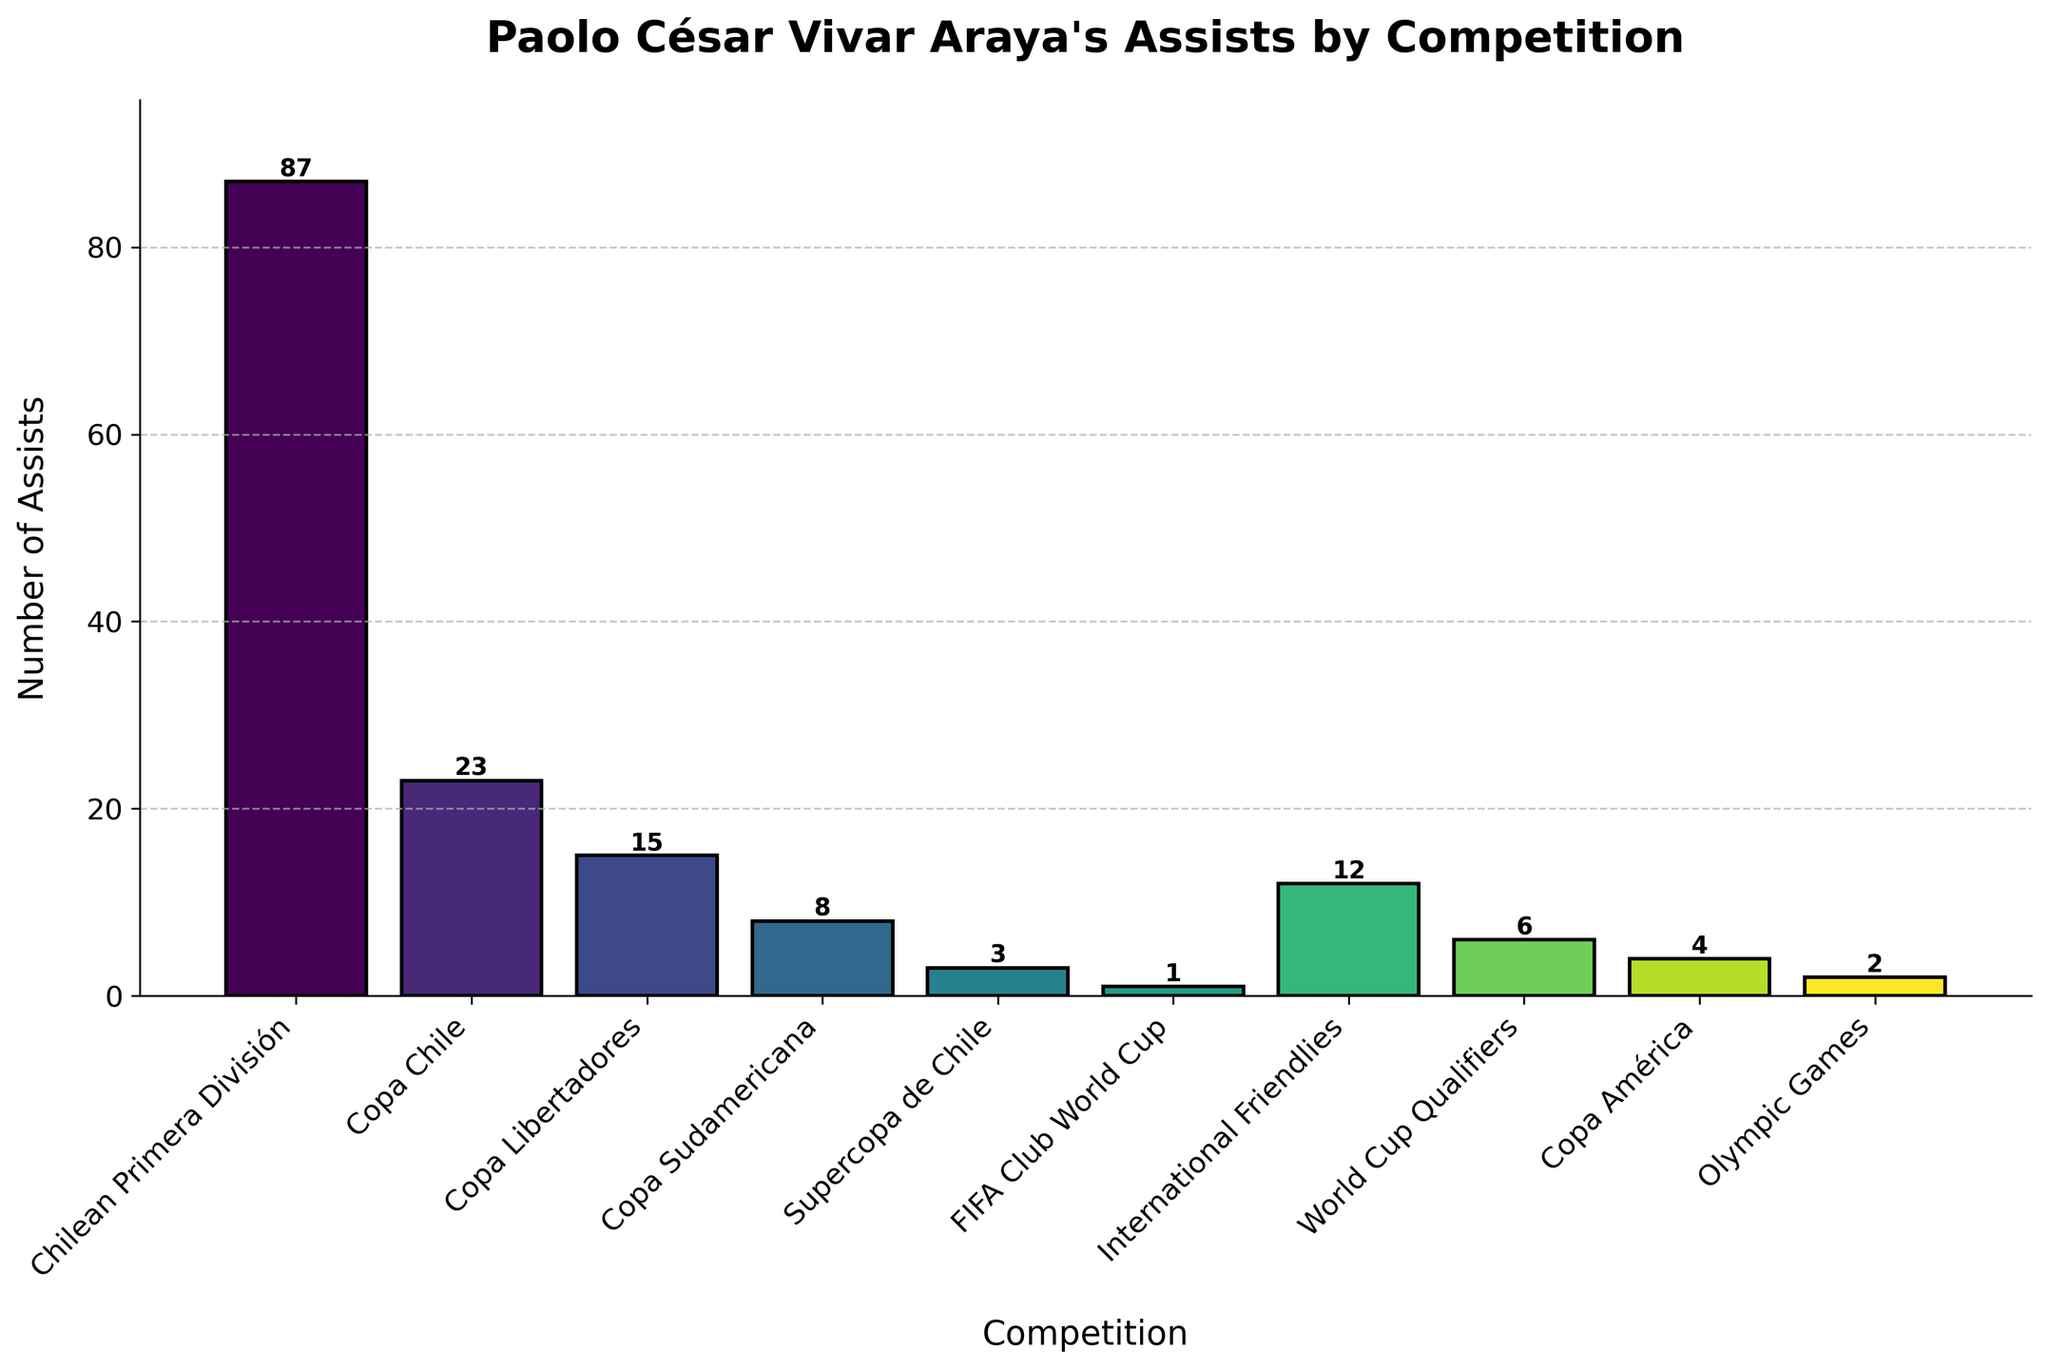Which competition has the highest number of assists? The bar representing the Chilean Primera División is the tallest on the chart, indicating the highest number of assists in that competition with 87.
Answer: Chilean Primera División Which competition has the second-highest number of assists? The bar for Copa Chile is the second tallest, with a height corresponding to 23 assists, making it the competition with the second-highest assists.
Answer: Copa Chile How many assists did Paolo César Vivar Araya make in competitions outside of Chilean leagues (Chilean Primera División and Copa Chile)? By summing the assists from competitions other than the Chilean leagues: 15 (Copa Libertadores) + 8 (Copa Sudamericana) + 3 (Supercopa de Chile) + 1 (FIFA Club World Cup) + 12 (International Friendlies) + 6 (World Cup Qualifiers) + 4 (Copa América ) + 2 (Olympic Games) = 51 assists.
Answer: 51 assists Which competition has fewer assists: Copa América or Olympic Games? By comparing the heights of the respective bars, the bar for the Olympic Games is shorter, indicating fewer assists (2) compared to Copa América (4).
Answer: Olympic Games What is the total number of assists made in international competitions (FIFA Club World Cup, International Friendlies, World Cup Qualifiers, Copa América, Olympic Games)? Summing the assists from all international competitions: 1 (FIFA Club World Cup) + 12 (International Friendlies) + 6 (World Cup Qualifiers) + 4 (Copa América) + 2 (Olympic Games) = 25 assists.
Answer: 25 assists Is the number of assists in Copa Libertadores greater than or equal to the total assists in both Copa Sudamericana and Supercopa de Chile? The assists in Copa Libertadores are 15, while the total in Copa Sudamericana and Supercopa de Chile combined is 8 + 3 = 11. Since 15 is greater than 11, the answer is yes.
Answer: Yes What is the combined total of assists in World Cup Qualifiers and Copa América? Adding the assists in both, World Cup Qualifiers (6) and Copa América (4): 6 + 4 = 10 assists.
Answer: 10 assists Which assist count is closer to the number in International Friendlies, World Cup Qualifiers or Copa Chile? Comparing the counts, International Friendlies have 12 assists, World Cup Qualifiers have 6, and Copa Chile has 23. The count for World Cup Qualifiers (6) is closer to 12 than Copa Chile (23).
Answer: World Cup Qualifiers Which competition has the fewest assists? By looking at the shortest bar in the chart, the FIFA Club World Cup has the fewest assists with only 1.
Answer: FIFA Club World Cup 